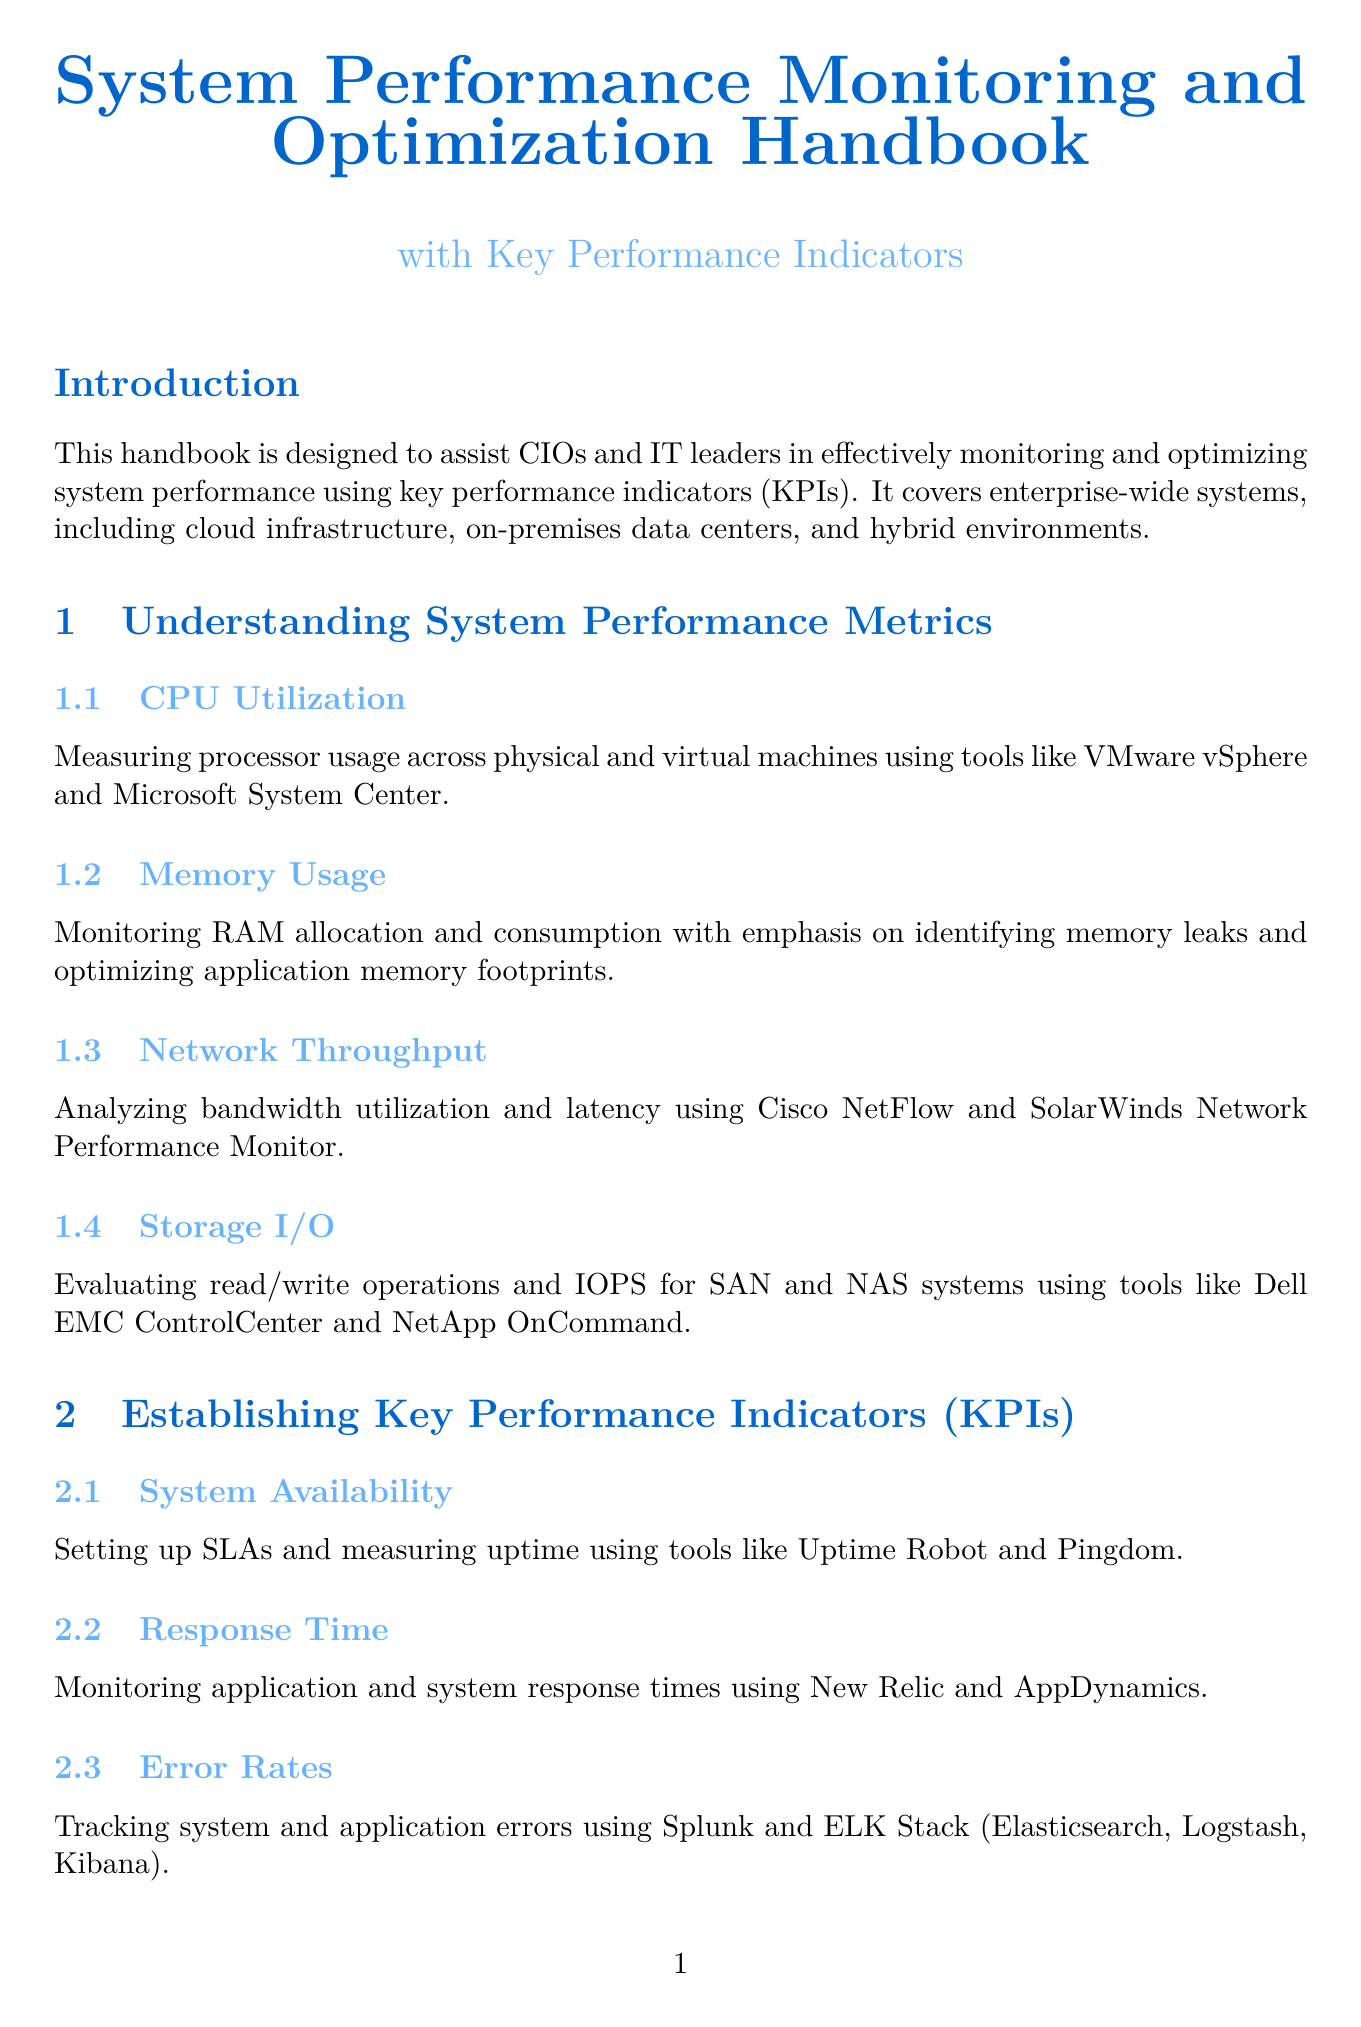What is the primary purpose of the handbook? The handbook is designed to assist CIOs and IT leaders in effectively monitoring and optimizing system performance using key performance indicators (KPIs).
Answer: assist CIOs and IT leaders Which chapter discusses CPU Utilization? CPU Utilization is a section under the chapter titled "Understanding System Performance Metrics."
Answer: Understanding System Performance Metrics What tools are mentioned for monitoring RAM allocation? The tools specified for monitoring RAM allocation and consumption are mentioned in the "Memory Usage" section.
Answer: identifying memory leaks What does the KPI "Response Time" focus on? "Response Time" focuses on monitoring application and system response times.
Answer: monitoring application and system response times Which performance optimization strategy utilizes predictive analytics? "Capacity Planning" is the performance optimization strategy that utilizes predictive analytics for resource allocation and scaling.
Answer: Capacity Planning What does APM stand for in the context of monitoring solutions? APM refers to Application Performance Management in the context of implementing performance monitoring solutions.
Answer: Application Performance Management What type of tools does the chapter on Continuous Improvement recommend for automated performance testing? The chapter on Continuous Improvement recommends tools like Apache JMeter and LoadRunner for automated performance testing.
Answer: Apache JMeter and LoadRunner What should CIOs regularly review according to the Next Steps? CIOs should regularly review and update KPIs as specified in the Next Steps of the conclusion.
Answer: KPIs 